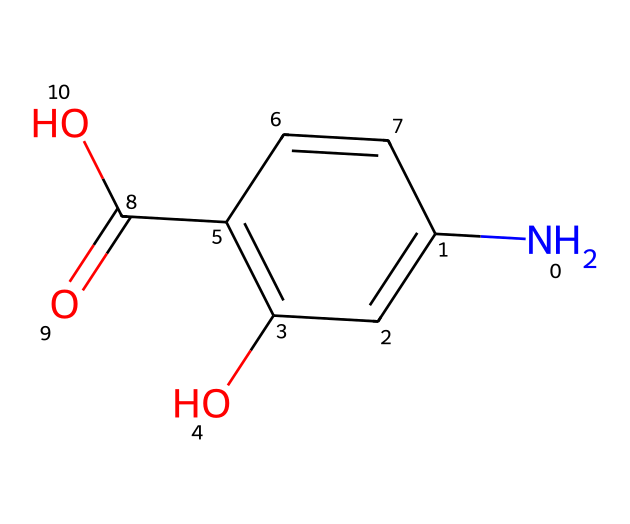How many carbon atoms are in mesalazine? By analyzing the SMILES representation, we count the number of carbon (C) symbols present. The structure contains six carbon atoms indicated by 'C' in the formula.
Answer: six What is the functional group present in mesalazine? Observing the SMILES, we notice the presence of a carboxylic acid group (–COOH), evidenced by 'C(=O)O' in the structure.
Answer: carboxylic acid How many nitrogen atoms are there in mesalazine? In the SMILES notation, there is one nitrogen atom represented by 'N,' indicating the presence of one nitrogen in the molecular structure.
Answer: one What type of compound is mesalazine? The chemical structure shows that mesalazine has an aromatic ring and functional groups typical of an anti-inflammatory drug, categorizing it as an anti-inflammatory compound.
Answer: anti-inflammatory Does mesalazine contain any halogens? Reviewing the SMILES representation, there are no halogen (F, Cl, Br, I, At) atoms present in the structure, which can be confirmed as there are no symbols corresponding to halogens.
Answer: no What is the total number of oxygen atoms in mesalazine? By examining the SMILES structure, we find three oxygen atoms present: one in the hydroxyl group (-OH) and two in the carboxylic acid (–COOH) group.
Answer: three What is the role of the hydroxyl group in mesalazine? The hydroxyl group (-OH) in the structure provides the compound with its solubility properties and contributes to its anti-inflammatory mechanism of action, making it essential for its efficacy as a medication.
Answer: solubility 